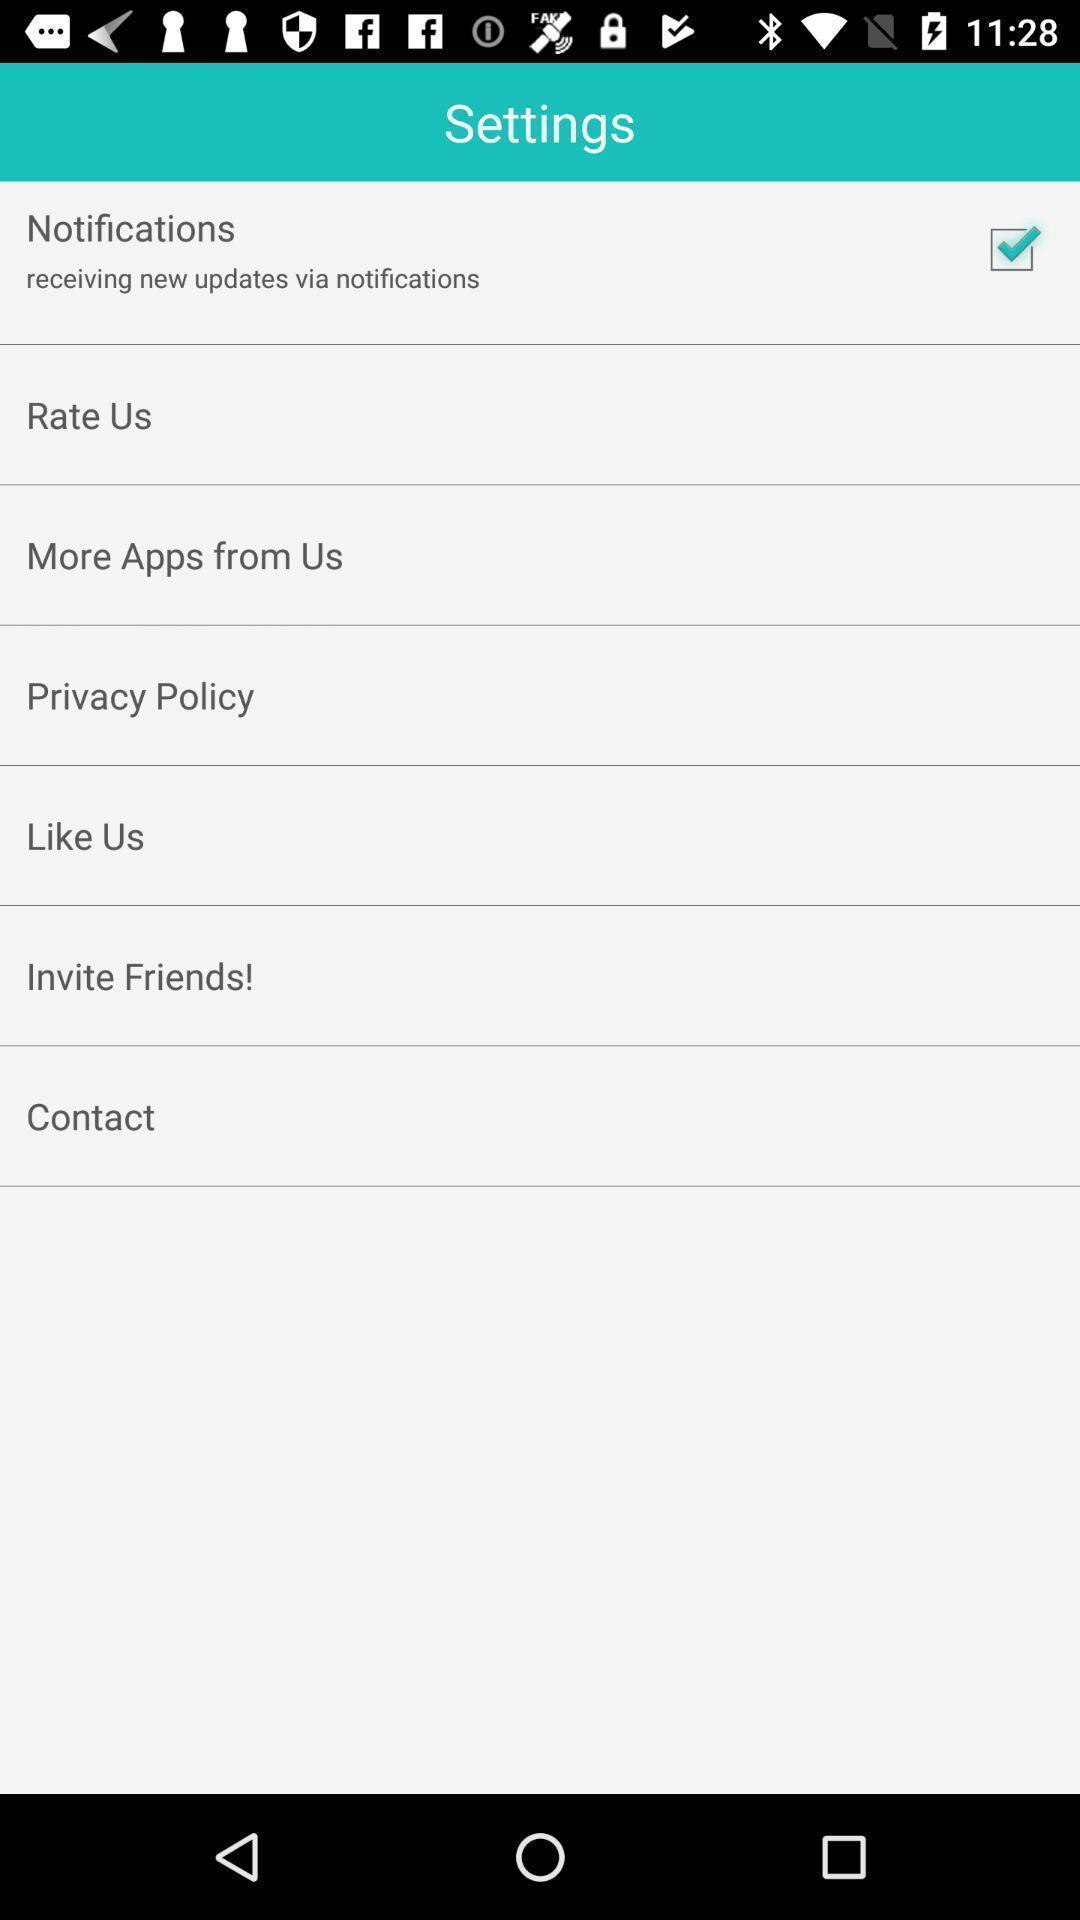Tell me what you see in this picture. Screen displaying list of settings on a business card app. 